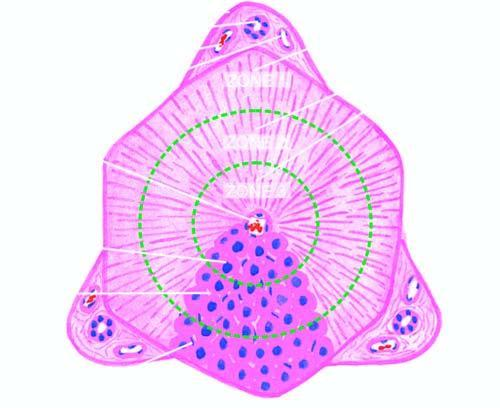s the hexagonal or pyramidal structure with central vein and peripheral 4 to 5 portal triads termed the classical lobule?
Answer the question using a single word or phrase. Yes 